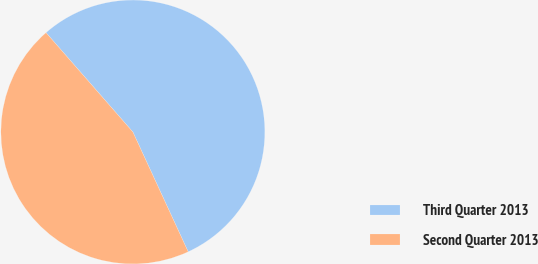Convert chart. <chart><loc_0><loc_0><loc_500><loc_500><pie_chart><fcel>Third Quarter 2013<fcel>Second Quarter 2013<nl><fcel>54.55%<fcel>45.45%<nl></chart> 